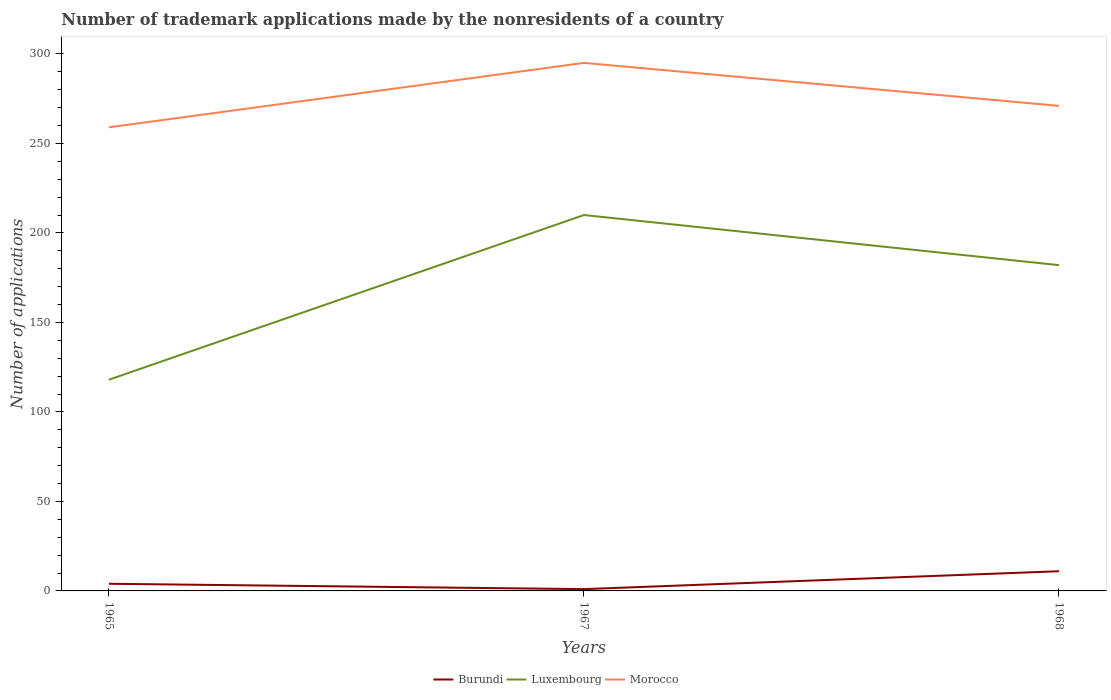Does the line corresponding to Burundi intersect with the line corresponding to Morocco?
Your response must be concise. No. Across all years, what is the maximum number of trademark applications made by the nonresidents in Burundi?
Give a very brief answer. 1. In which year was the number of trademark applications made by the nonresidents in Burundi maximum?
Offer a terse response. 1967. What is the total number of trademark applications made by the nonresidents in Morocco in the graph?
Offer a terse response. -36. What is the difference between the highest and the lowest number of trademark applications made by the nonresidents in Burundi?
Provide a short and direct response. 1. Is the number of trademark applications made by the nonresidents in Burundi strictly greater than the number of trademark applications made by the nonresidents in Luxembourg over the years?
Offer a very short reply. Yes. What is the difference between two consecutive major ticks on the Y-axis?
Provide a short and direct response. 50. Does the graph contain grids?
Your answer should be very brief. No. What is the title of the graph?
Your answer should be compact. Number of trademark applications made by the nonresidents of a country. Does "Lithuania" appear as one of the legend labels in the graph?
Offer a terse response. No. What is the label or title of the X-axis?
Offer a terse response. Years. What is the label or title of the Y-axis?
Offer a terse response. Number of applications. What is the Number of applications in Burundi in 1965?
Your answer should be compact. 4. What is the Number of applications in Luxembourg in 1965?
Provide a short and direct response. 118. What is the Number of applications of Morocco in 1965?
Your answer should be compact. 259. What is the Number of applications of Luxembourg in 1967?
Your answer should be very brief. 210. What is the Number of applications in Morocco in 1967?
Make the answer very short. 295. What is the Number of applications of Burundi in 1968?
Keep it short and to the point. 11. What is the Number of applications in Luxembourg in 1968?
Provide a succinct answer. 182. What is the Number of applications of Morocco in 1968?
Make the answer very short. 271. Across all years, what is the maximum Number of applications in Luxembourg?
Give a very brief answer. 210. Across all years, what is the maximum Number of applications in Morocco?
Provide a succinct answer. 295. Across all years, what is the minimum Number of applications of Burundi?
Ensure brevity in your answer.  1. Across all years, what is the minimum Number of applications of Luxembourg?
Your response must be concise. 118. Across all years, what is the minimum Number of applications of Morocco?
Ensure brevity in your answer.  259. What is the total Number of applications of Luxembourg in the graph?
Keep it short and to the point. 510. What is the total Number of applications in Morocco in the graph?
Offer a very short reply. 825. What is the difference between the Number of applications in Burundi in 1965 and that in 1967?
Your response must be concise. 3. What is the difference between the Number of applications in Luxembourg in 1965 and that in 1967?
Keep it short and to the point. -92. What is the difference between the Number of applications of Morocco in 1965 and that in 1967?
Your answer should be compact. -36. What is the difference between the Number of applications in Burundi in 1965 and that in 1968?
Keep it short and to the point. -7. What is the difference between the Number of applications in Luxembourg in 1965 and that in 1968?
Your answer should be very brief. -64. What is the difference between the Number of applications in Burundi in 1967 and that in 1968?
Your answer should be compact. -10. What is the difference between the Number of applications in Morocco in 1967 and that in 1968?
Your answer should be very brief. 24. What is the difference between the Number of applications of Burundi in 1965 and the Number of applications of Luxembourg in 1967?
Provide a short and direct response. -206. What is the difference between the Number of applications of Burundi in 1965 and the Number of applications of Morocco in 1967?
Provide a short and direct response. -291. What is the difference between the Number of applications in Luxembourg in 1965 and the Number of applications in Morocco in 1967?
Make the answer very short. -177. What is the difference between the Number of applications of Burundi in 1965 and the Number of applications of Luxembourg in 1968?
Your answer should be very brief. -178. What is the difference between the Number of applications in Burundi in 1965 and the Number of applications in Morocco in 1968?
Keep it short and to the point. -267. What is the difference between the Number of applications of Luxembourg in 1965 and the Number of applications of Morocco in 1968?
Provide a succinct answer. -153. What is the difference between the Number of applications in Burundi in 1967 and the Number of applications in Luxembourg in 1968?
Provide a short and direct response. -181. What is the difference between the Number of applications in Burundi in 1967 and the Number of applications in Morocco in 1968?
Your response must be concise. -270. What is the difference between the Number of applications of Luxembourg in 1967 and the Number of applications of Morocco in 1968?
Offer a very short reply. -61. What is the average Number of applications in Burundi per year?
Give a very brief answer. 5.33. What is the average Number of applications in Luxembourg per year?
Provide a short and direct response. 170. What is the average Number of applications in Morocco per year?
Provide a succinct answer. 275. In the year 1965, what is the difference between the Number of applications in Burundi and Number of applications in Luxembourg?
Your response must be concise. -114. In the year 1965, what is the difference between the Number of applications of Burundi and Number of applications of Morocco?
Your answer should be very brief. -255. In the year 1965, what is the difference between the Number of applications of Luxembourg and Number of applications of Morocco?
Keep it short and to the point. -141. In the year 1967, what is the difference between the Number of applications of Burundi and Number of applications of Luxembourg?
Your answer should be very brief. -209. In the year 1967, what is the difference between the Number of applications of Burundi and Number of applications of Morocco?
Ensure brevity in your answer.  -294. In the year 1967, what is the difference between the Number of applications of Luxembourg and Number of applications of Morocco?
Your response must be concise. -85. In the year 1968, what is the difference between the Number of applications in Burundi and Number of applications in Luxembourg?
Provide a succinct answer. -171. In the year 1968, what is the difference between the Number of applications in Burundi and Number of applications in Morocco?
Keep it short and to the point. -260. In the year 1968, what is the difference between the Number of applications in Luxembourg and Number of applications in Morocco?
Offer a terse response. -89. What is the ratio of the Number of applications in Burundi in 1965 to that in 1967?
Your answer should be compact. 4. What is the ratio of the Number of applications of Luxembourg in 1965 to that in 1967?
Offer a very short reply. 0.56. What is the ratio of the Number of applications of Morocco in 1965 to that in 1967?
Ensure brevity in your answer.  0.88. What is the ratio of the Number of applications in Burundi in 1965 to that in 1968?
Offer a very short reply. 0.36. What is the ratio of the Number of applications in Luxembourg in 1965 to that in 1968?
Offer a terse response. 0.65. What is the ratio of the Number of applications in Morocco in 1965 to that in 1968?
Ensure brevity in your answer.  0.96. What is the ratio of the Number of applications of Burundi in 1967 to that in 1968?
Offer a very short reply. 0.09. What is the ratio of the Number of applications of Luxembourg in 1967 to that in 1968?
Offer a very short reply. 1.15. What is the ratio of the Number of applications in Morocco in 1967 to that in 1968?
Make the answer very short. 1.09. What is the difference between the highest and the lowest Number of applications in Burundi?
Make the answer very short. 10. What is the difference between the highest and the lowest Number of applications in Luxembourg?
Ensure brevity in your answer.  92. 